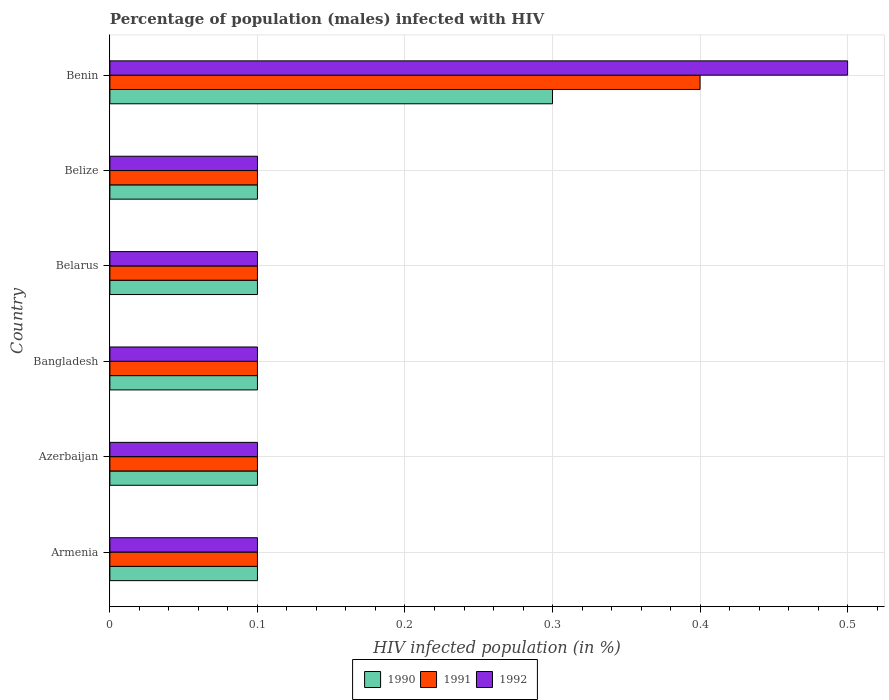How many different coloured bars are there?
Provide a short and direct response. 3. How many groups of bars are there?
Give a very brief answer. 6. Are the number of bars on each tick of the Y-axis equal?
Your answer should be very brief. Yes. How many bars are there on the 6th tick from the top?
Offer a terse response. 3. How many bars are there on the 2nd tick from the bottom?
Ensure brevity in your answer.  3. What is the label of the 1st group of bars from the top?
Offer a very short reply. Benin. In how many cases, is the number of bars for a given country not equal to the number of legend labels?
Your response must be concise. 0. Across all countries, what is the maximum percentage of HIV infected male population in 1990?
Offer a terse response. 0.3. Across all countries, what is the minimum percentage of HIV infected male population in 1991?
Your answer should be very brief. 0.1. In which country was the percentage of HIV infected male population in 1991 maximum?
Keep it short and to the point. Benin. In which country was the percentage of HIV infected male population in 1990 minimum?
Ensure brevity in your answer.  Armenia. What is the total percentage of HIV infected male population in 1991 in the graph?
Offer a very short reply. 0.9. What is the difference between the percentage of HIV infected male population in 1990 in Azerbaijan and that in Belize?
Your answer should be very brief. 0. What is the difference between the percentage of HIV infected male population in 1990 in Bangladesh and the percentage of HIV infected male population in 1991 in Benin?
Offer a very short reply. -0.3. What is the average percentage of HIV infected male population in 1992 per country?
Your response must be concise. 0.17. What is the difference between the percentage of HIV infected male population in 1991 and percentage of HIV infected male population in 1990 in Benin?
Make the answer very short. 0.1. In how many countries, is the percentage of HIV infected male population in 1990 greater than 0.48000000000000004 %?
Offer a terse response. 0. What is the ratio of the percentage of HIV infected male population in 1991 in Belize to that in Benin?
Your response must be concise. 0.25. Is the difference between the percentage of HIV infected male population in 1991 in Azerbaijan and Belarus greater than the difference between the percentage of HIV infected male population in 1990 in Azerbaijan and Belarus?
Make the answer very short. No. What is the difference between the highest and the second highest percentage of HIV infected male population in 1990?
Offer a terse response. 0.2. What is the difference between the highest and the lowest percentage of HIV infected male population in 1991?
Your answer should be compact. 0.3. What does the 3rd bar from the top in Benin represents?
Provide a succinct answer. 1990. What does the 1st bar from the bottom in Belarus represents?
Provide a short and direct response. 1990. What is the difference between two consecutive major ticks on the X-axis?
Ensure brevity in your answer.  0.1. Does the graph contain any zero values?
Your response must be concise. No. Does the graph contain grids?
Your answer should be very brief. Yes. Where does the legend appear in the graph?
Offer a very short reply. Bottom center. How many legend labels are there?
Make the answer very short. 3. What is the title of the graph?
Your answer should be very brief. Percentage of population (males) infected with HIV. What is the label or title of the X-axis?
Ensure brevity in your answer.  HIV infected population (in %). What is the HIV infected population (in %) in 1990 in Armenia?
Give a very brief answer. 0.1. What is the HIV infected population (in %) in 1992 in Armenia?
Offer a very short reply. 0.1. What is the HIV infected population (in %) of 1990 in Azerbaijan?
Give a very brief answer. 0.1. What is the HIV infected population (in %) in 1991 in Azerbaijan?
Offer a terse response. 0.1. What is the HIV infected population (in %) in 1992 in Azerbaijan?
Keep it short and to the point. 0.1. What is the HIV infected population (in %) of 1991 in Bangladesh?
Make the answer very short. 0.1. What is the HIV infected population (in %) in 1991 in Belarus?
Your answer should be compact. 0.1. What is the HIV infected population (in %) of 1992 in Belarus?
Provide a succinct answer. 0.1. What is the HIV infected population (in %) in 1991 in Belize?
Provide a short and direct response. 0.1. What is the HIV infected population (in %) in 1992 in Belize?
Provide a short and direct response. 0.1. What is the HIV infected population (in %) of 1990 in Benin?
Provide a succinct answer. 0.3. What is the HIV infected population (in %) in 1992 in Benin?
Provide a short and direct response. 0.5. Across all countries, what is the maximum HIV infected population (in %) in 1992?
Your answer should be compact. 0.5. Across all countries, what is the minimum HIV infected population (in %) in 1990?
Keep it short and to the point. 0.1. Across all countries, what is the minimum HIV infected population (in %) of 1992?
Offer a terse response. 0.1. What is the total HIV infected population (in %) in 1991 in the graph?
Your answer should be very brief. 0.9. What is the difference between the HIV infected population (in %) of 1990 in Armenia and that in Azerbaijan?
Your answer should be very brief. 0. What is the difference between the HIV infected population (in %) of 1991 in Armenia and that in Azerbaijan?
Ensure brevity in your answer.  0. What is the difference between the HIV infected population (in %) of 1990 in Armenia and that in Bangladesh?
Offer a very short reply. 0. What is the difference between the HIV infected population (in %) in 1991 in Armenia and that in Bangladesh?
Your answer should be compact. 0. What is the difference between the HIV infected population (in %) of 1990 in Armenia and that in Belarus?
Your response must be concise. 0. What is the difference between the HIV infected population (in %) of 1991 in Armenia and that in Belarus?
Your response must be concise. 0. What is the difference between the HIV infected population (in %) in 1992 in Armenia and that in Belarus?
Make the answer very short. 0. What is the difference between the HIV infected population (in %) in 1990 in Armenia and that in Belize?
Keep it short and to the point. 0. What is the difference between the HIV infected population (in %) in 1992 in Armenia and that in Benin?
Offer a very short reply. -0.4. What is the difference between the HIV infected population (in %) of 1990 in Azerbaijan and that in Bangladesh?
Your answer should be very brief. 0. What is the difference between the HIV infected population (in %) of 1992 in Azerbaijan and that in Bangladesh?
Provide a succinct answer. 0. What is the difference between the HIV infected population (in %) in 1992 in Azerbaijan and that in Belarus?
Give a very brief answer. 0. What is the difference between the HIV infected population (in %) in 1990 in Bangladesh and that in Belarus?
Offer a very short reply. 0. What is the difference between the HIV infected population (in %) in 1991 in Bangladesh and that in Belarus?
Offer a terse response. 0. What is the difference between the HIV infected population (in %) in 1992 in Bangladesh and that in Belarus?
Your answer should be compact. 0. What is the difference between the HIV infected population (in %) of 1990 in Bangladesh and that in Belize?
Ensure brevity in your answer.  0. What is the difference between the HIV infected population (in %) of 1990 in Bangladesh and that in Benin?
Give a very brief answer. -0.2. What is the difference between the HIV infected population (in %) in 1992 in Bangladesh and that in Benin?
Your answer should be compact. -0.4. What is the difference between the HIV infected population (in %) in 1991 in Belarus and that in Belize?
Your response must be concise. 0. What is the difference between the HIV infected population (in %) of 1992 in Belarus and that in Belize?
Ensure brevity in your answer.  0. What is the difference between the HIV infected population (in %) in 1991 in Belarus and that in Benin?
Offer a very short reply. -0.3. What is the difference between the HIV infected population (in %) in 1990 in Belize and that in Benin?
Your response must be concise. -0.2. What is the difference between the HIV infected population (in %) of 1991 in Belize and that in Benin?
Give a very brief answer. -0.3. What is the difference between the HIV infected population (in %) in 1990 in Armenia and the HIV infected population (in %) in 1992 in Azerbaijan?
Give a very brief answer. 0. What is the difference between the HIV infected population (in %) in 1991 in Armenia and the HIV infected population (in %) in 1992 in Azerbaijan?
Your response must be concise. 0. What is the difference between the HIV infected population (in %) of 1990 in Armenia and the HIV infected population (in %) of 1992 in Bangladesh?
Provide a succinct answer. 0. What is the difference between the HIV infected population (in %) in 1990 in Armenia and the HIV infected population (in %) in 1991 in Belarus?
Provide a succinct answer. 0. What is the difference between the HIV infected population (in %) in 1991 in Armenia and the HIV infected population (in %) in 1992 in Belarus?
Provide a short and direct response. 0. What is the difference between the HIV infected population (in %) in 1990 in Armenia and the HIV infected population (in %) in 1991 in Belize?
Your response must be concise. 0. What is the difference between the HIV infected population (in %) of 1991 in Armenia and the HIV infected population (in %) of 1992 in Belize?
Your response must be concise. 0. What is the difference between the HIV infected population (in %) of 1990 in Armenia and the HIV infected population (in %) of 1991 in Benin?
Ensure brevity in your answer.  -0.3. What is the difference between the HIV infected population (in %) in 1990 in Azerbaijan and the HIV infected population (in %) in 1991 in Bangladesh?
Your response must be concise. 0. What is the difference between the HIV infected population (in %) in 1991 in Azerbaijan and the HIV infected population (in %) in 1992 in Bangladesh?
Keep it short and to the point. 0. What is the difference between the HIV infected population (in %) of 1990 in Azerbaijan and the HIV infected population (in %) of 1992 in Belize?
Keep it short and to the point. 0. What is the difference between the HIV infected population (in %) of 1990 in Azerbaijan and the HIV infected population (in %) of 1992 in Benin?
Your answer should be compact. -0.4. What is the difference between the HIV infected population (in %) of 1990 in Bangladesh and the HIV infected population (in %) of 1992 in Belarus?
Provide a short and direct response. 0. What is the difference between the HIV infected population (in %) of 1990 in Bangladesh and the HIV infected population (in %) of 1991 in Belize?
Offer a terse response. 0. What is the difference between the HIV infected population (in %) of 1990 in Bangladesh and the HIV infected population (in %) of 1992 in Belize?
Make the answer very short. 0. What is the difference between the HIV infected population (in %) of 1991 in Bangladesh and the HIV infected population (in %) of 1992 in Belize?
Offer a very short reply. 0. What is the difference between the HIV infected population (in %) in 1990 in Bangladesh and the HIV infected population (in %) in 1991 in Benin?
Keep it short and to the point. -0.3. What is the difference between the HIV infected population (in %) of 1991 in Bangladesh and the HIV infected population (in %) of 1992 in Benin?
Your response must be concise. -0.4. What is the difference between the HIV infected population (in %) of 1990 in Belarus and the HIV infected population (in %) of 1991 in Belize?
Keep it short and to the point. 0. What is the difference between the HIV infected population (in %) of 1990 in Belarus and the HIV infected population (in %) of 1991 in Benin?
Provide a succinct answer. -0.3. What is the difference between the HIV infected population (in %) in 1991 in Belarus and the HIV infected population (in %) in 1992 in Benin?
Your response must be concise. -0.4. What is the average HIV infected population (in %) of 1990 per country?
Make the answer very short. 0.13. What is the average HIV infected population (in %) of 1991 per country?
Ensure brevity in your answer.  0.15. What is the difference between the HIV infected population (in %) of 1990 and HIV infected population (in %) of 1991 in Armenia?
Provide a short and direct response. 0. What is the difference between the HIV infected population (in %) in 1990 and HIV infected population (in %) in 1992 in Armenia?
Your answer should be very brief. 0. What is the difference between the HIV infected population (in %) of 1991 and HIV infected population (in %) of 1992 in Armenia?
Provide a succinct answer. 0. What is the difference between the HIV infected population (in %) in 1990 and HIV infected population (in %) in 1992 in Azerbaijan?
Ensure brevity in your answer.  0. What is the difference between the HIV infected population (in %) of 1991 and HIV infected population (in %) of 1992 in Azerbaijan?
Give a very brief answer. 0. What is the difference between the HIV infected population (in %) in 1990 and HIV infected population (in %) in 1991 in Bangladesh?
Ensure brevity in your answer.  0. What is the difference between the HIV infected population (in %) of 1991 and HIV infected population (in %) of 1992 in Bangladesh?
Provide a succinct answer. 0. What is the difference between the HIV infected population (in %) in 1990 and HIV infected population (in %) in 1992 in Belarus?
Offer a terse response. 0. What is the difference between the HIV infected population (in %) of 1990 and HIV infected population (in %) of 1991 in Belize?
Make the answer very short. 0. What is the difference between the HIV infected population (in %) in 1990 and HIV infected population (in %) in 1992 in Belize?
Your response must be concise. 0. What is the difference between the HIV infected population (in %) of 1991 and HIV infected population (in %) of 1992 in Belize?
Ensure brevity in your answer.  0. What is the difference between the HIV infected population (in %) of 1990 and HIV infected population (in %) of 1991 in Benin?
Your answer should be very brief. -0.1. What is the difference between the HIV infected population (in %) of 1990 and HIV infected population (in %) of 1992 in Benin?
Provide a succinct answer. -0.2. What is the difference between the HIV infected population (in %) of 1991 and HIV infected population (in %) of 1992 in Benin?
Provide a short and direct response. -0.1. What is the ratio of the HIV infected population (in %) of 1990 in Armenia to that in Azerbaijan?
Your response must be concise. 1. What is the ratio of the HIV infected population (in %) of 1990 in Armenia to that in Bangladesh?
Your answer should be very brief. 1. What is the ratio of the HIV infected population (in %) in 1991 in Armenia to that in Bangladesh?
Ensure brevity in your answer.  1. What is the ratio of the HIV infected population (in %) of 1992 in Armenia to that in Bangladesh?
Ensure brevity in your answer.  1. What is the ratio of the HIV infected population (in %) of 1990 in Armenia to that in Belarus?
Provide a short and direct response. 1. What is the ratio of the HIV infected population (in %) in 1990 in Armenia to that in Belize?
Your answer should be compact. 1. What is the ratio of the HIV infected population (in %) in 1991 in Armenia to that in Belize?
Give a very brief answer. 1. What is the ratio of the HIV infected population (in %) of 1992 in Armenia to that in Benin?
Keep it short and to the point. 0.2. What is the ratio of the HIV infected population (in %) of 1990 in Azerbaijan to that in Bangladesh?
Your response must be concise. 1. What is the ratio of the HIV infected population (in %) of 1991 in Azerbaijan to that in Belarus?
Your response must be concise. 1. What is the ratio of the HIV infected population (in %) of 1990 in Azerbaijan to that in Belize?
Offer a terse response. 1. What is the ratio of the HIV infected population (in %) in 1992 in Azerbaijan to that in Belize?
Offer a terse response. 1. What is the ratio of the HIV infected population (in %) of 1990 in Azerbaijan to that in Benin?
Give a very brief answer. 0.33. What is the ratio of the HIV infected population (in %) of 1991 in Azerbaijan to that in Benin?
Offer a very short reply. 0.25. What is the ratio of the HIV infected population (in %) in 1992 in Azerbaijan to that in Benin?
Offer a terse response. 0.2. What is the ratio of the HIV infected population (in %) of 1991 in Bangladesh to that in Belarus?
Your answer should be compact. 1. What is the ratio of the HIV infected population (in %) of 1990 in Bangladesh to that in Belize?
Offer a terse response. 1. What is the ratio of the HIV infected population (in %) in 1991 in Bangladesh to that in Belize?
Keep it short and to the point. 1. What is the ratio of the HIV infected population (in %) of 1992 in Bangladesh to that in Belize?
Your response must be concise. 1. What is the ratio of the HIV infected population (in %) in 1991 in Bangladesh to that in Benin?
Your answer should be very brief. 0.25. What is the ratio of the HIV infected population (in %) of 1992 in Bangladesh to that in Benin?
Provide a short and direct response. 0.2. What is the ratio of the HIV infected population (in %) in 1990 in Belarus to that in Belize?
Offer a terse response. 1. What is the ratio of the HIV infected population (in %) in 1992 in Belarus to that in Benin?
Your response must be concise. 0.2. What is the ratio of the HIV infected population (in %) in 1991 in Belize to that in Benin?
Give a very brief answer. 0.25. What is the difference between the highest and the second highest HIV infected population (in %) of 1992?
Offer a very short reply. 0.4. What is the difference between the highest and the lowest HIV infected population (in %) in 1990?
Ensure brevity in your answer.  0.2. What is the difference between the highest and the lowest HIV infected population (in %) of 1992?
Your answer should be very brief. 0.4. 